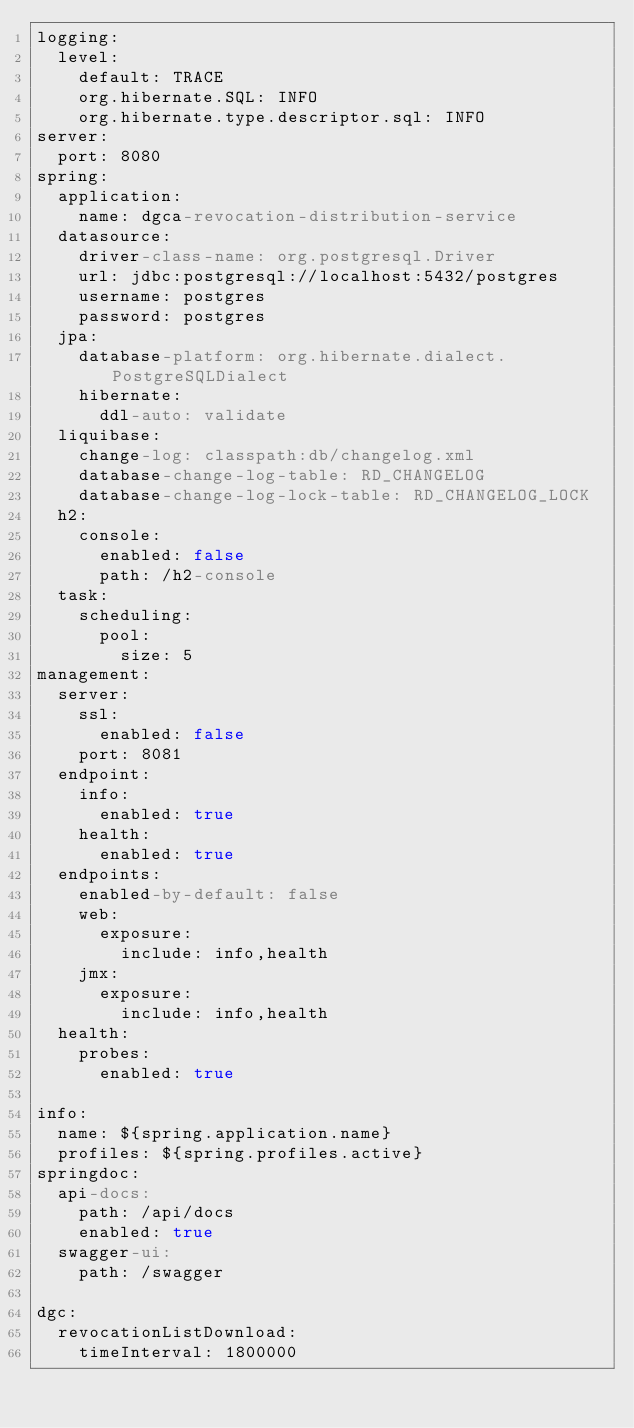<code> <loc_0><loc_0><loc_500><loc_500><_YAML_>logging:
  level:
    default: TRACE
    org.hibernate.SQL: INFO
    org.hibernate.type.descriptor.sql: INFO
server:
  port: 8080
spring:
  application:
    name: dgca-revocation-distribution-service
  datasource:
    driver-class-name: org.postgresql.Driver
    url: jdbc:postgresql://localhost:5432/postgres
    username: postgres
    password: postgres
  jpa:
    database-platform: org.hibernate.dialect.PostgreSQLDialect
    hibernate:
      ddl-auto: validate
  liquibase:
    change-log: classpath:db/changelog.xml
    database-change-log-table: RD_CHANGELOG
    database-change-log-lock-table: RD_CHANGELOG_LOCK
  h2:
    console:
      enabled: false
      path: /h2-console
  task:
    scheduling:
      pool:
        size: 5
management:
  server:
    ssl:
      enabled: false
    port: 8081
  endpoint:
    info:
      enabled: true
    health:
      enabled: true
  endpoints:
    enabled-by-default: false
    web:
      exposure:
        include: info,health
    jmx:
      exposure:
        include: info,health
  health:
    probes:
      enabled: true

info:
  name: ${spring.application.name}
  profiles: ${spring.profiles.active}
springdoc:
  api-docs:
    path: /api/docs
    enabled: true
  swagger-ui:
    path: /swagger

dgc:
  revocationListDownload:
    timeInterval: 1800000</code> 